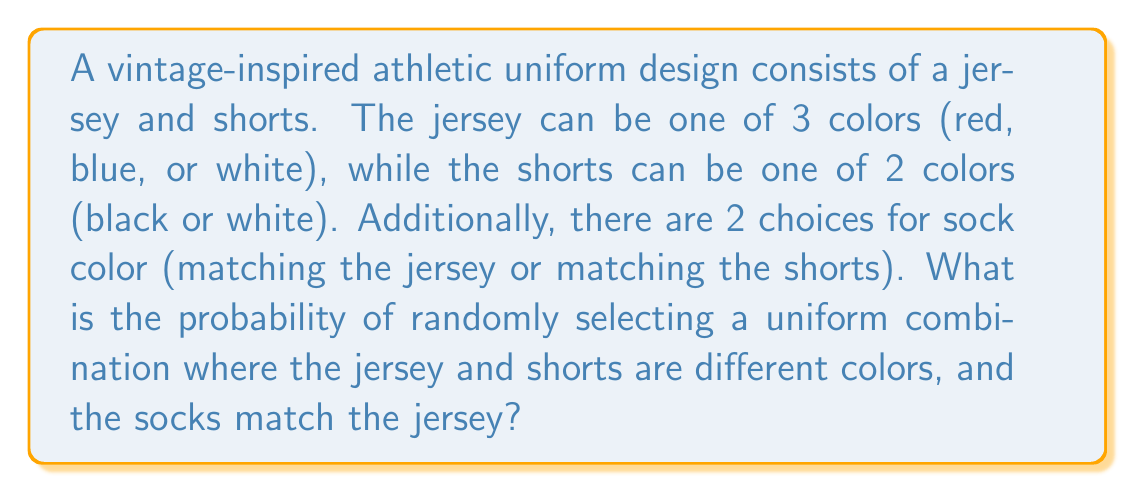Solve this math problem. Let's break this down step-by-step:

1) First, we need to calculate the total number of possible uniform combinations:
   - 3 choices for jersey color
   - 2 choices for shorts color
   - 2 choices for sock color
   Total combinations: $3 \times 2 \times 2 = 12$

2) Now, let's identify the favorable outcomes:
   - Jersey and shorts must be different colors:
     * Red jersey with black shorts
     * Blue jersey with black shorts
     * White jersey with black shorts
   - Socks must match the jersey color

3) Let's count these favorable outcomes:
   - Red jersey, black shorts, red socks
   - Blue jersey, black shorts, blue socks
   - White jersey, black shorts, white socks
   Total favorable outcomes: 3

4) The probability is calculated as:

   $$P(\text{favorable outcome}) = \frac{\text{number of favorable outcomes}}{\text{total number of possible outcomes}}$$

   $$P = \frac{3}{12} = \frac{1}{4} = 0.25$$
Answer: $\frac{1}{4}$ or $0.25$ or $25\%$ 